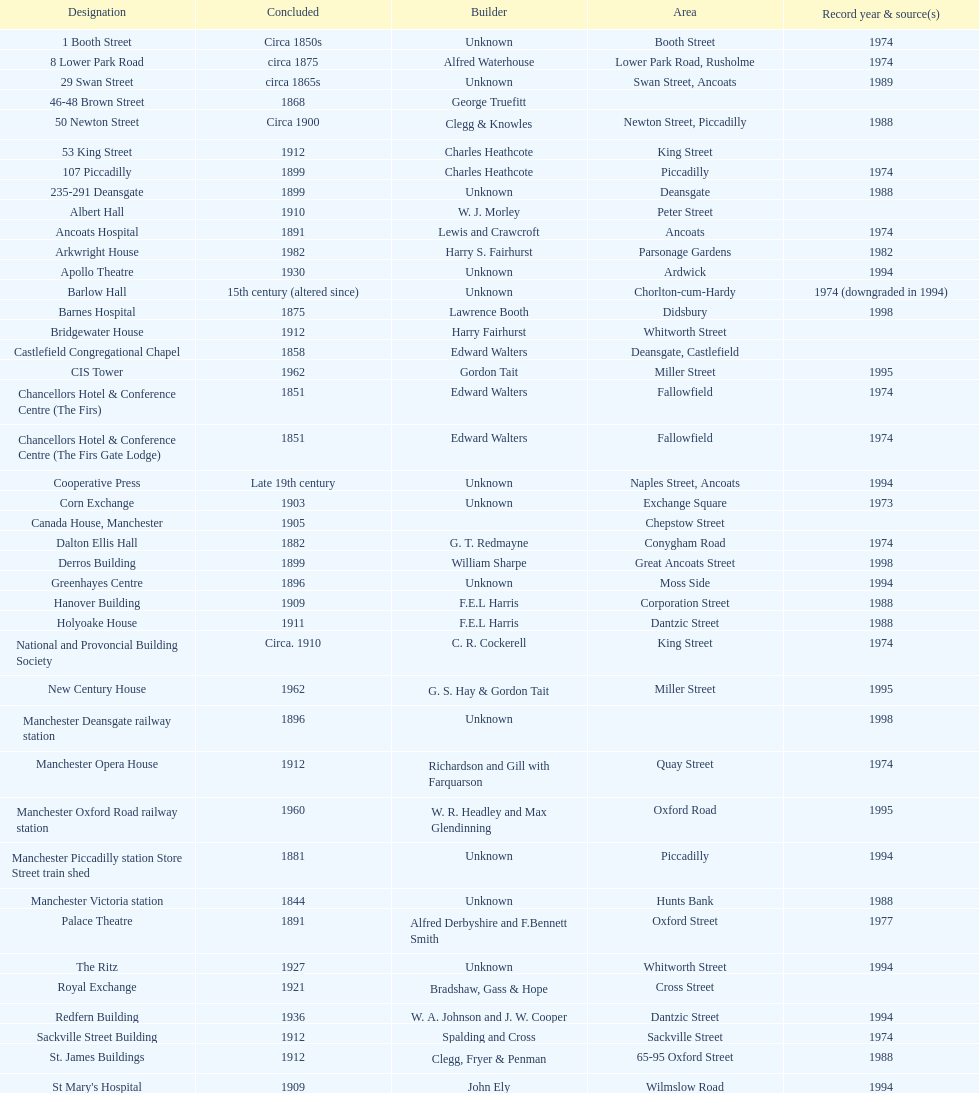Was charles heathcote the architect of ancoats hospital and apollo theatre? No. 